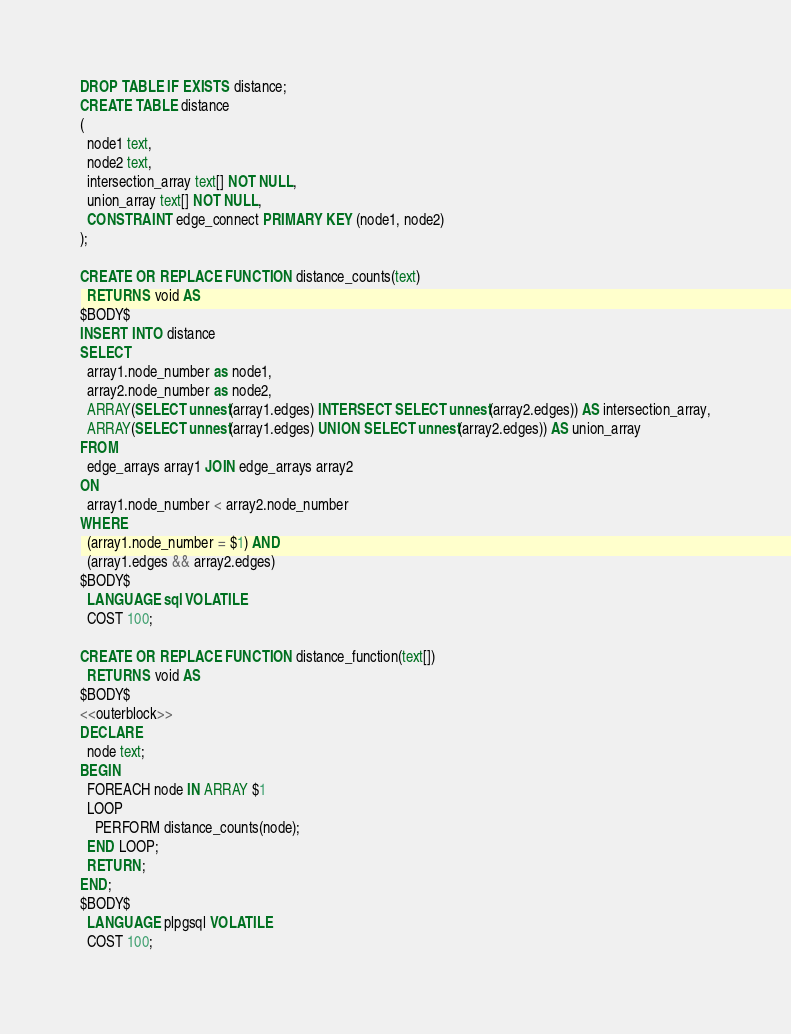Convert code to text. <code><loc_0><loc_0><loc_500><loc_500><_SQL_>
DROP TABLE IF EXISTS distance;
CREATE TABLE distance 
(
  node1 text,
  node2 text,
  intersection_array text[] NOT NULL,
  union_array text[] NOT NULL,
  CONSTRAINT edge_connect PRIMARY KEY (node1, node2)
);

CREATE OR REPLACE FUNCTION distance_counts(text)
  RETURNS void AS
$BODY$
INSERT INTO distance
SELECT
  array1.node_number as node1,
  array2.node_number as node2,
  ARRAY(SELECT unnest(array1.edges) INTERSECT SELECT unnest(array2.edges)) AS intersection_array,
  ARRAY(SELECT unnest(array1.edges) UNION SELECT unnest(array2.edges)) AS union_array
FROM
  edge_arrays array1 JOIN edge_arrays array2
ON
  array1.node_number < array2.node_number
WHERE
  (array1.node_number = $1) AND
  (array1.edges && array2.edges)
$BODY$
  LANGUAGE sql VOLATILE
  COST 100;

CREATE OR REPLACE FUNCTION distance_function(text[])
  RETURNS void AS
$BODY$
<<outerblock>>
DECLARE
  node text;
BEGIN
  FOREACH node IN ARRAY $1
  LOOP
    PERFORM distance_counts(node);
  END LOOP;
  RETURN;
END;
$BODY$
  LANGUAGE plpgsql VOLATILE
  COST 100;


</code> 